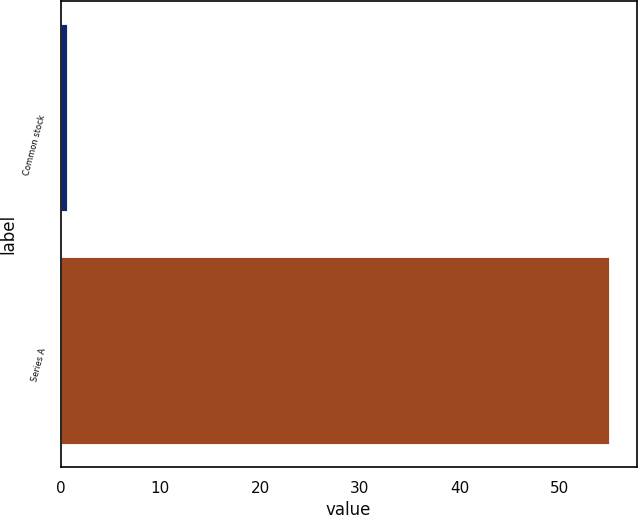Convert chart. <chart><loc_0><loc_0><loc_500><loc_500><bar_chart><fcel>Common stock<fcel>Series A<nl><fcel>0.64<fcel>55<nl></chart> 